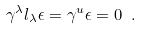<formula> <loc_0><loc_0><loc_500><loc_500>\gamma ^ { \lambda } l _ { \lambda } \epsilon = \gamma ^ { u } \epsilon = 0 \ .</formula> 